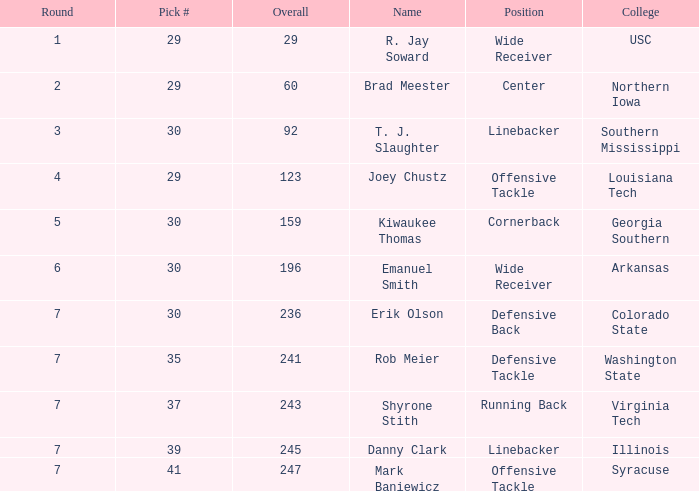What is the highest Pick that is wide receiver with overall of 29? 29.0. Could you parse the entire table as a dict? {'header': ['Round', 'Pick #', 'Overall', 'Name', 'Position', 'College'], 'rows': [['1', '29', '29', 'R. Jay Soward', 'Wide Receiver', 'USC'], ['2', '29', '60', 'Brad Meester', 'Center', 'Northern Iowa'], ['3', '30', '92', 'T. J. Slaughter', 'Linebacker', 'Southern Mississippi'], ['4', '29', '123', 'Joey Chustz', 'Offensive Tackle', 'Louisiana Tech'], ['5', '30', '159', 'Kiwaukee Thomas', 'Cornerback', 'Georgia Southern'], ['6', '30', '196', 'Emanuel Smith', 'Wide Receiver', 'Arkansas'], ['7', '30', '236', 'Erik Olson', 'Defensive Back', 'Colorado State'], ['7', '35', '241', 'Rob Meier', 'Defensive Tackle', 'Washington State'], ['7', '37', '243', 'Shyrone Stith', 'Running Back', 'Virginia Tech'], ['7', '39', '245', 'Danny Clark', 'Linebacker', 'Illinois'], ['7', '41', '247', 'Mark Baniewicz', 'Offensive Tackle', 'Syracuse']]} 